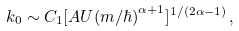Convert formula to latex. <formula><loc_0><loc_0><loc_500><loc_500>k _ { 0 } \sim C _ { 1 } [ A U ( m / \hbar { ) } ^ { \alpha + 1 } ] ^ { 1 / ( 2 \alpha - 1 ) } \, ,</formula> 